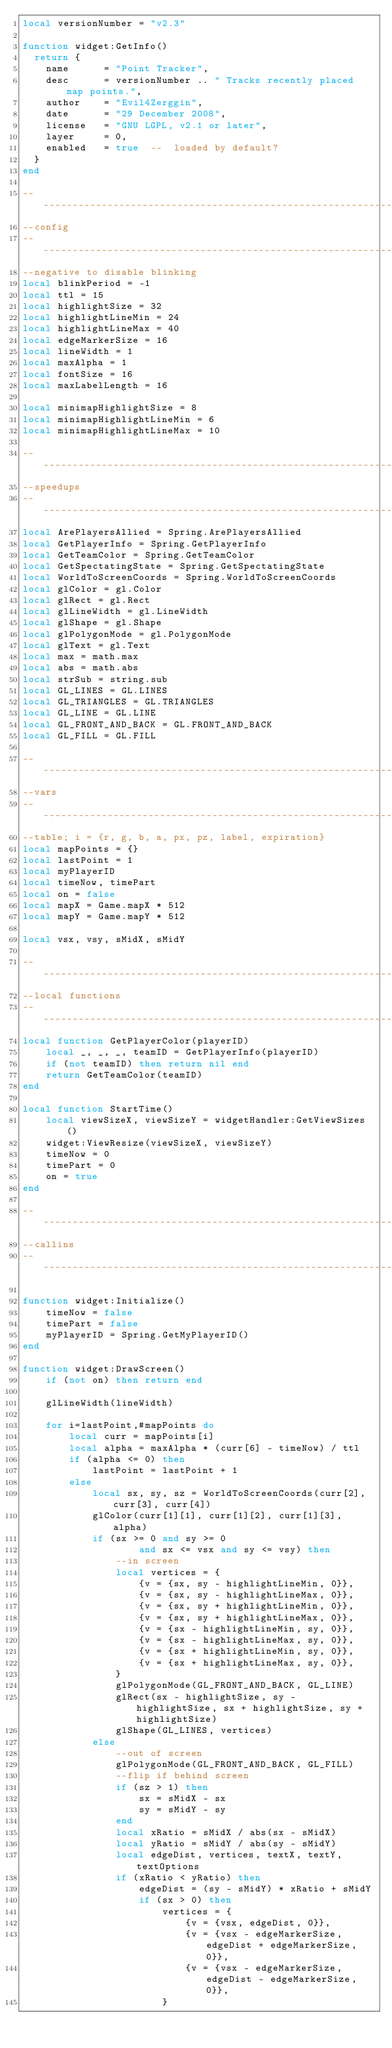<code> <loc_0><loc_0><loc_500><loc_500><_Lua_>local versionNumber = "v2.3"

function widget:GetInfo()
  return {
    name      = "Point Tracker",
    desc      = versionNumber .. " Tracks recently placed map points.",
    author    = "Evil4Zerggin",
    date      = "29 December 2008",
    license   = "GNU LGPL, v2.1 or later",
    layer     = 0,
    enabled   = true  --  loaded by default?
  }
end

----------------------------------------------------------------
--config
----------------------------------------------------------------
--negative to disable blinking
local blinkPeriod = -1
local ttl = 15
local highlightSize = 32
local highlightLineMin = 24
local highlightLineMax = 40
local edgeMarkerSize = 16
local lineWidth = 1
local maxAlpha = 1
local fontSize = 16
local maxLabelLength = 16

local minimapHighlightSize = 8
local minimapHighlightLineMin = 6
local minimapHighlightLineMax = 10

----------------------------------------------------------------
--speedups
----------------------------------------------------------------
local ArePlayersAllied = Spring.ArePlayersAllied
local GetPlayerInfo = Spring.GetPlayerInfo
local GetTeamColor = Spring.GetTeamColor
local GetSpectatingState = Spring.GetSpectatingState
local WorldToScreenCoords = Spring.WorldToScreenCoords
local glColor = gl.Color
local glRect = gl.Rect
local glLineWidth = gl.LineWidth
local glShape = gl.Shape
local glPolygonMode = gl.PolygonMode
local glText = gl.Text
local max = math.max
local abs = math.abs
local strSub = string.sub
local GL_LINES = GL.LINES
local GL_TRIANGLES = GL.TRIANGLES
local GL_LINE = GL.LINE
local GL_FRONT_AND_BACK = GL.FRONT_AND_BACK
local GL_FILL = GL.FILL

----------------------------------------------------------------
--vars
----------------------------------------------------------------
--table; i = {r, g, b, a, px, pz, label, expiration}
local mapPoints = {}
local lastPoint = 1
local myPlayerID
local timeNow, timePart
local on = false
local mapX = Game.mapX * 512
local mapY = Game.mapY * 512

local vsx, vsy, sMidX, sMidY

----------------------------------------------------------------
--local functions
----------------------------------------------------------------
local function GetPlayerColor(playerID)
	local _, _, _, teamID = GetPlayerInfo(playerID)
	if (not teamID) then return nil end
	return GetTeamColor(teamID)
end

local function StartTime()
	local viewSizeX, viewSizeY = widgetHandler:GetViewSizes()
	widget:ViewResize(viewSizeX, viewSizeY)
	timeNow = 0
	timePart = 0
	on = true
end

----------------------------------------------------------------
--callins
----------------------------------------------------------------

function widget:Initialize()
	timeNow = false
	timePart = false
	myPlayerID = Spring.GetMyPlayerID()
end

function widget:DrawScreen()
	if (not on) then return end
	
	glLineWidth(lineWidth)
	
	for i=lastPoint,#mapPoints do
		local curr = mapPoints[i]
		local alpha = maxAlpha * (curr[6] - timeNow) / ttl
		if (alpha <= 0) then
			lastPoint = lastPoint + 1
		else
			local sx, sy, sz = WorldToScreenCoords(curr[2], curr[3], curr[4])
			glColor(curr[1][1], curr[1][2], curr[1][3], alpha)
			if (sx >= 0 and sy >= 0
					and sx <= vsx and sy <= vsy) then
				--in screen
				local vertices = {
					{v = {sx, sy - highlightLineMin, 0}},
					{v = {sx, sy - highlightLineMax, 0}},
					{v = {sx, sy + highlightLineMin, 0}},
					{v = {sx, sy + highlightLineMax, 0}},
					{v = {sx - highlightLineMin, sy, 0}},
					{v = {sx - highlightLineMax, sy, 0}},
					{v = {sx + highlightLineMin, sy, 0}},
					{v = {sx + highlightLineMax, sy, 0}},
				}
				glPolygonMode(GL_FRONT_AND_BACK, GL_LINE)
				glRect(sx - highlightSize, sy - highlightSize, sx + highlightSize, sy + highlightSize)
				glShape(GL_LINES, vertices)
			else
				--out of screen
				glPolygonMode(GL_FRONT_AND_BACK, GL_FILL)
				--flip if behind screen
				if (sz > 1) then
					sx = sMidX - sx
					sy = sMidY - sy
				end
				local xRatio = sMidX / abs(sx - sMidX)
				local yRatio = sMidY / abs(sy - sMidY)
				local edgeDist, vertices, textX, textY, textOptions
				if (xRatio < yRatio) then
					edgeDist = (sy - sMidY) * xRatio + sMidY
					if (sx > 0) then
						vertices = {
							{v = {vsx, edgeDist, 0}},
							{v = {vsx - edgeMarkerSize, edgeDist + edgeMarkerSize, 0}},
							{v = {vsx - edgeMarkerSize, edgeDist - edgeMarkerSize, 0}},
						}</code> 